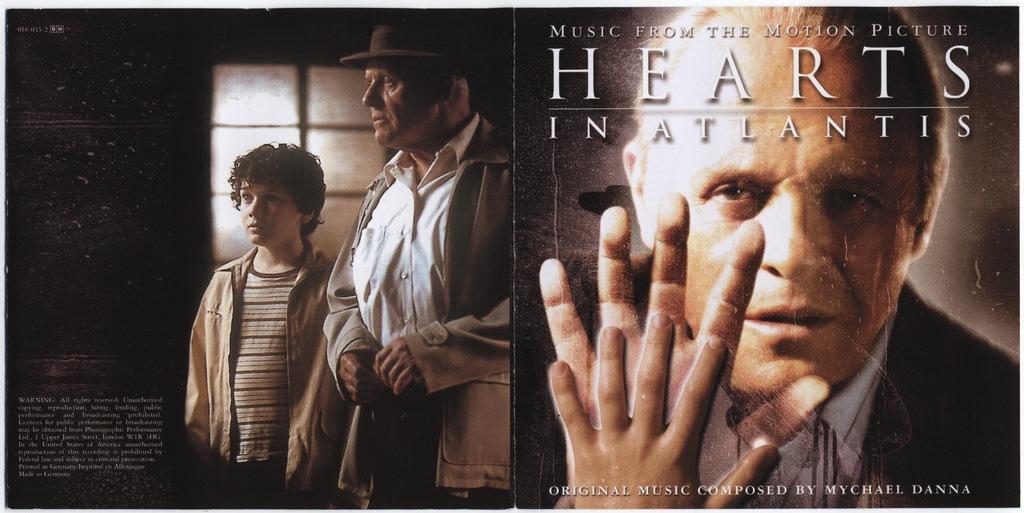Can you describe this image briefly? This image looks like a poster. I can see the man and a boy standing. These are the letters in the image. This looks like a window. This man wore a hat, jerkin, shirt and trouser. I think this is an edited image. 